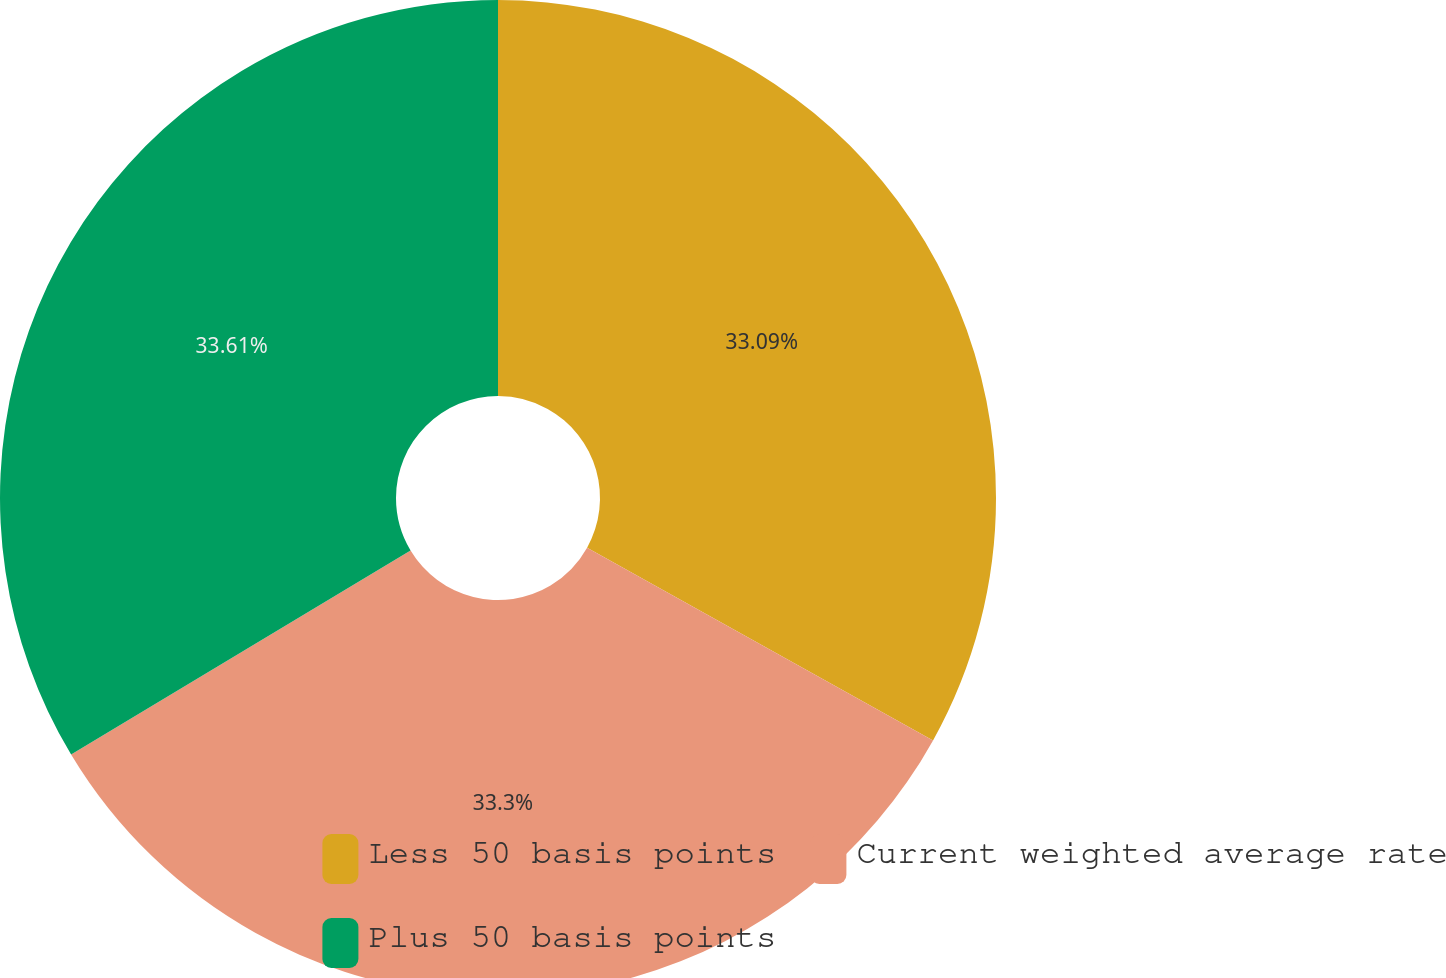<chart> <loc_0><loc_0><loc_500><loc_500><pie_chart><fcel>Less 50 basis points<fcel>Current weighted average rate<fcel>Plus 50 basis points<nl><fcel>33.09%<fcel>33.3%<fcel>33.61%<nl></chart> 